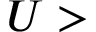<formula> <loc_0><loc_0><loc_500><loc_500>U ></formula> 